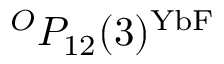<formula> <loc_0><loc_0><loc_500><loc_500>^ { O } P _ { 1 2 } ( 3 ) ^ { Y b F }</formula> 